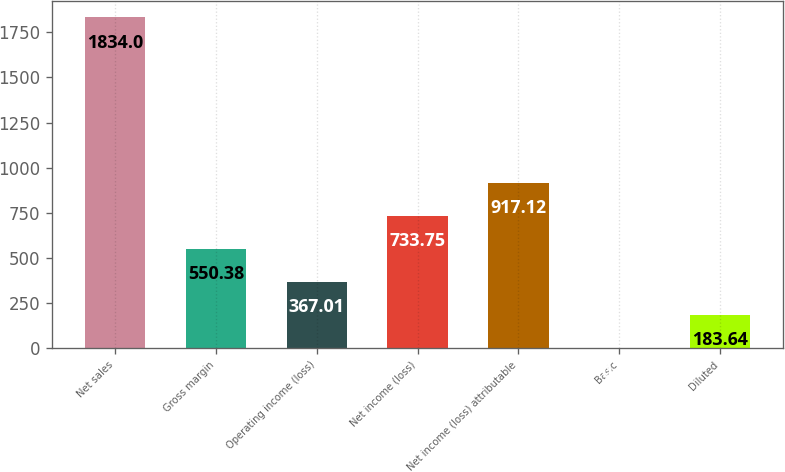Convert chart to OTSL. <chart><loc_0><loc_0><loc_500><loc_500><bar_chart><fcel>Net sales<fcel>Gross margin<fcel>Operating income (loss)<fcel>Net income (loss)<fcel>Net income (loss) attributable<fcel>Basic<fcel>Diluted<nl><fcel>1834<fcel>550.38<fcel>367.01<fcel>733.75<fcel>917.12<fcel>0.27<fcel>183.64<nl></chart> 